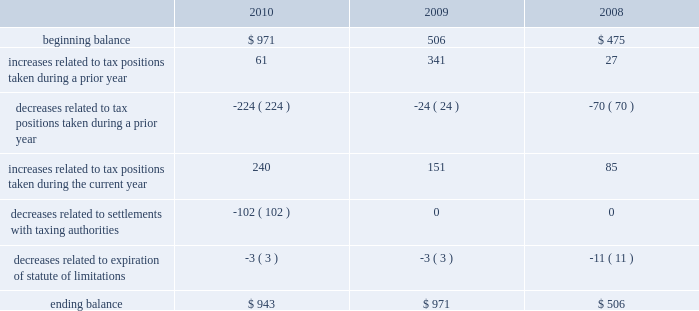Table of contents the aggregate changes in the balance of gross unrecognized tax benefits , which excludes interest and penalties , for the three years ended september 25 , 2010 , is as follows ( in millions ) : the company includes interest and penalties related to unrecognized tax benefits within the provision for income taxes .
As of september 25 , 2010 and september 26 , 2009 , the total amount of gross interest and penalties accrued was $ 247 million and $ 291 million , respectively , which is classified as non-current liabilities in the consolidated balance sheets .
In 2010 and 2009 , the company recognized an interest benefit of $ 43 million and interest expense of $ 64 million , respectively , in connection with tax matters .
The company is subject to taxation and files income tax returns in the u.s .
Federal jurisdiction and in many state and foreign jurisdictions .
For u.s .
Federal income tax purposes , all years prior to 2004 are closed .
The internal revenue service ( the 201cirs 201d ) has completed its field audit of the company 2019s federal income tax returns for the years 2004 through 2006 and proposed certain adjustments .
The company has contested certain of these adjustments through the irs appeals office .
The irs is currently examining the years 2007 through 2009 .
During the third quarter of 2010 , the company reached a tax settlement with the irs for the years 2002 through 2003 .
In connection with the settlement , the company reduced its gross unrecognized tax benefits by $ 100 million and recognized a $ 52 million tax benefit in the third quarter of 2010 .
In addition , the company is also subject to audits by state , local and foreign tax authorities .
In major states and major foreign jurisdictions , the years subsequent to 1988 and 2001 , respectively , generally remain open and could be subject to examination by the taxing authorities .
Management believes that an adequate provision has been made for any adjustments that may result from tax examinations .
However , the outcome of tax audits cannot be predicted with certainty .
If any issues addressed in the company 2019s tax audits are resolved in a manner not consistent with management 2019s expectations , the company could be required to adjust its provision for income tax in the period such resolution occurs .
Although timing of the resolution and/or closure of audits is not certain , the company does not believe it is reasonably possible that its unrecognized tax benefits would materially change in the next 12 months .
Note 7 2013 shareholders 2019 equity and stock-based compensation preferred stock the company has five million shares of authorized preferred stock , none of which is issued or outstanding .
Under the terms of the company 2019s restated articles of incorporation , the board of directors is authorized to determine or alter the rights , preferences , privileges and restrictions of the company 2019s authorized but unissued shares of preferred stock .
Comprehensive income comprehensive income consists of two components , net income and other comprehensive income .
Other comprehensive income refers to revenue , expenses , gains and losses that under gaap are recorded as an element of shareholders 2019 equity but are excluded from net income .
The company 2019s other comprehensive income consists .

What was the smallest decrease related to expiration of statute of limitations for the three year period , in millions? 
Computations: table_min(decreases related to expiration of statute of limitations, none)
Answer: -11.0. 